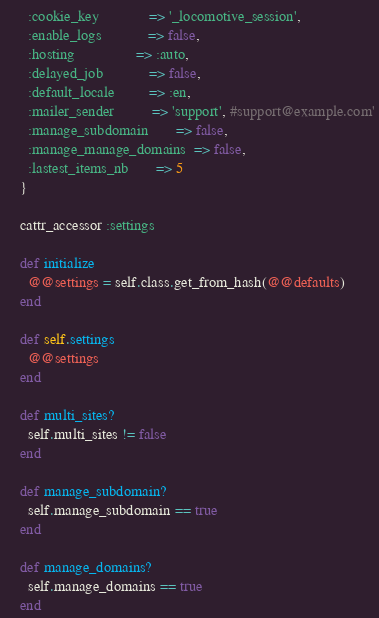Convert code to text. <code><loc_0><loc_0><loc_500><loc_500><_Ruby_>      :cookie_key             => '_locomotive_session',
      :enable_logs            => false,
      :hosting                => :auto,
      :delayed_job            => false,
      :default_locale         => :en,
      :mailer_sender          => 'support', #support@example.com'
      :manage_subdomain       => false,
      :manage_manage_domains  => false,
      :lastest_items_nb       => 5
    }

    cattr_accessor :settings

    def initialize
      @@settings = self.class.get_from_hash(@@defaults)
    end

    def self.settings
      @@settings
    end

    def multi_sites?
      self.multi_sites != false
    end

    def manage_subdomain?
      self.manage_subdomain == true
    end

    def manage_domains?
      self.manage_domains == true
    end
</code> 